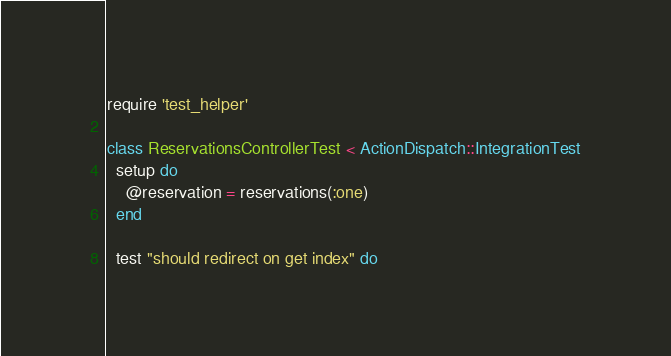<code> <loc_0><loc_0><loc_500><loc_500><_Ruby_>require 'test_helper'

class ReservationsControllerTest < ActionDispatch::IntegrationTest
  setup do
    @reservation = reservations(:one)
  end

  test "should redirect on get index" do</code> 